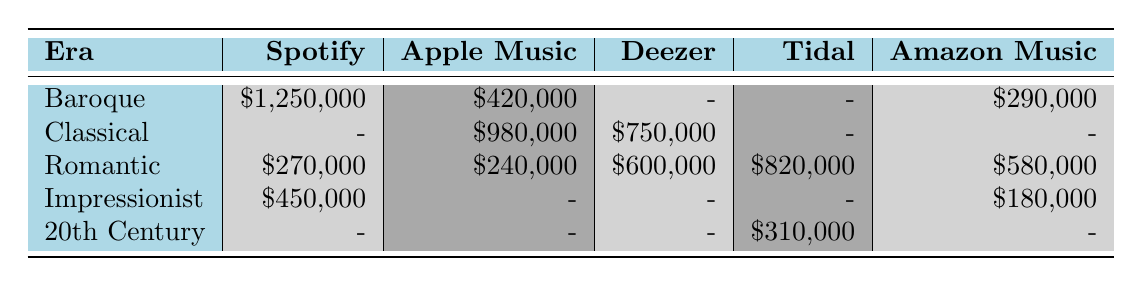What platform generated the highest revenue for the Baroque era? The table shows that Spotify generated the highest revenue for the Baroque era at $1,250,000. Other platforms either did not generate revenue for this era or had lower amounts.
Answer: Spotify Which platform had the highest total revenue for the Romantic era? By examining the Romantic era's row, we see Tidal had the highest revenue at $820,000 compared to other platforms: Deezer at $600,000, Amazon Music at $580,000, and Spotify at $270,000.
Answer: Tidal Is there any revenue generated for the Classical era on Spotify? Looking at the Classical row, it is evident that Spotify did not generate any revenue for this era, as it is marked with a dash (-).
Answer: No What is the total revenue generated from Impressionist composers across all platforms? The revenue for Impressionist composers sums up to $450,000 from Spotify and $180,000 from Amazon Music, totaling $450,000 + $180,000 = $630,000.
Answer: $630,000 Which era generated the least revenue on Apple Music? When analyzing the revenues for Apple Music, the lowest is found in the Impressionist era, where no revenue is generated (marked by a dash). The other eras show $980,000 for Classical and $240,000 for Romantic.
Answer: Impressionist What is the average revenue across all platforms for the Baroque era? The total for the Baroque era can be calculated by adding $1,250,000 (Spotify) + $420,000 (Apple Music) + $290,000 (Amazon Music), which equals $1,960,000. There are three entries, so the average is $1,960,000 / 3 = $653,333.33.
Answer: $653,333.33 True or False: Deezer generated revenue in all five eras. A review of Deezer's entries shows that they did not generate revenue for the Baroque or Impressionist eras, indicated by the dashes (-). Therefore, the statement is true.
Answer: False What was the combined revenue for all streaming platforms for the 20th Century era? There is only one entry for the 20th Century era, which shows Tidal with $310,000 revenue. Thus, its combined revenue is simply $310,000.
Answer: $310,000 